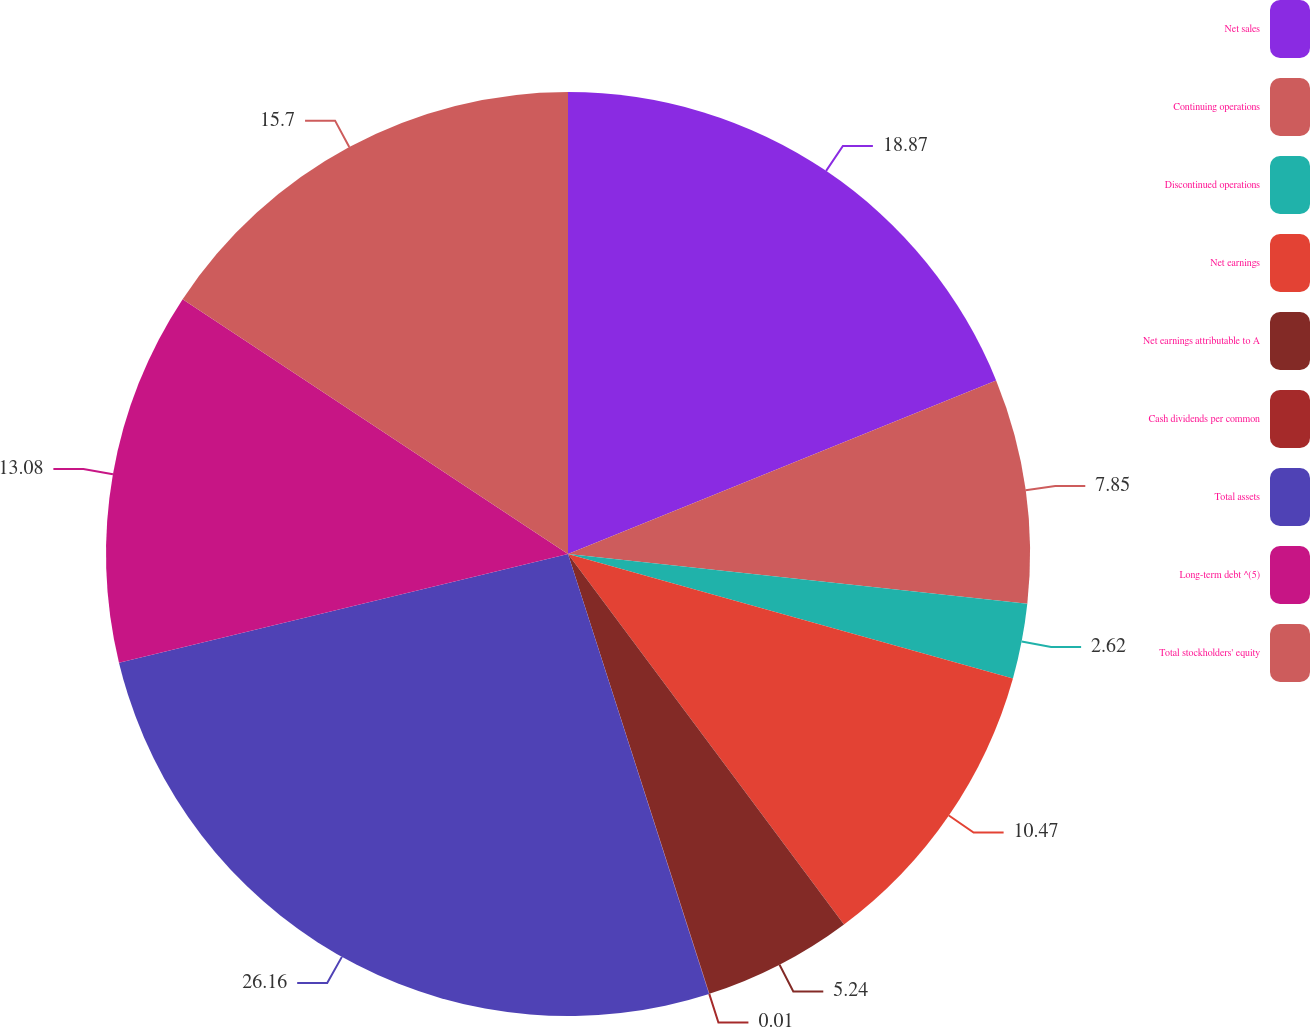Convert chart to OTSL. <chart><loc_0><loc_0><loc_500><loc_500><pie_chart><fcel>Net sales<fcel>Continuing operations<fcel>Discontinued operations<fcel>Net earnings<fcel>Net earnings attributable to A<fcel>Cash dividends per common<fcel>Total assets<fcel>Long-term debt ^(5)<fcel>Total stockholders' equity<nl><fcel>18.87%<fcel>7.85%<fcel>2.62%<fcel>10.47%<fcel>5.24%<fcel>0.01%<fcel>26.16%<fcel>13.08%<fcel>15.7%<nl></chart> 